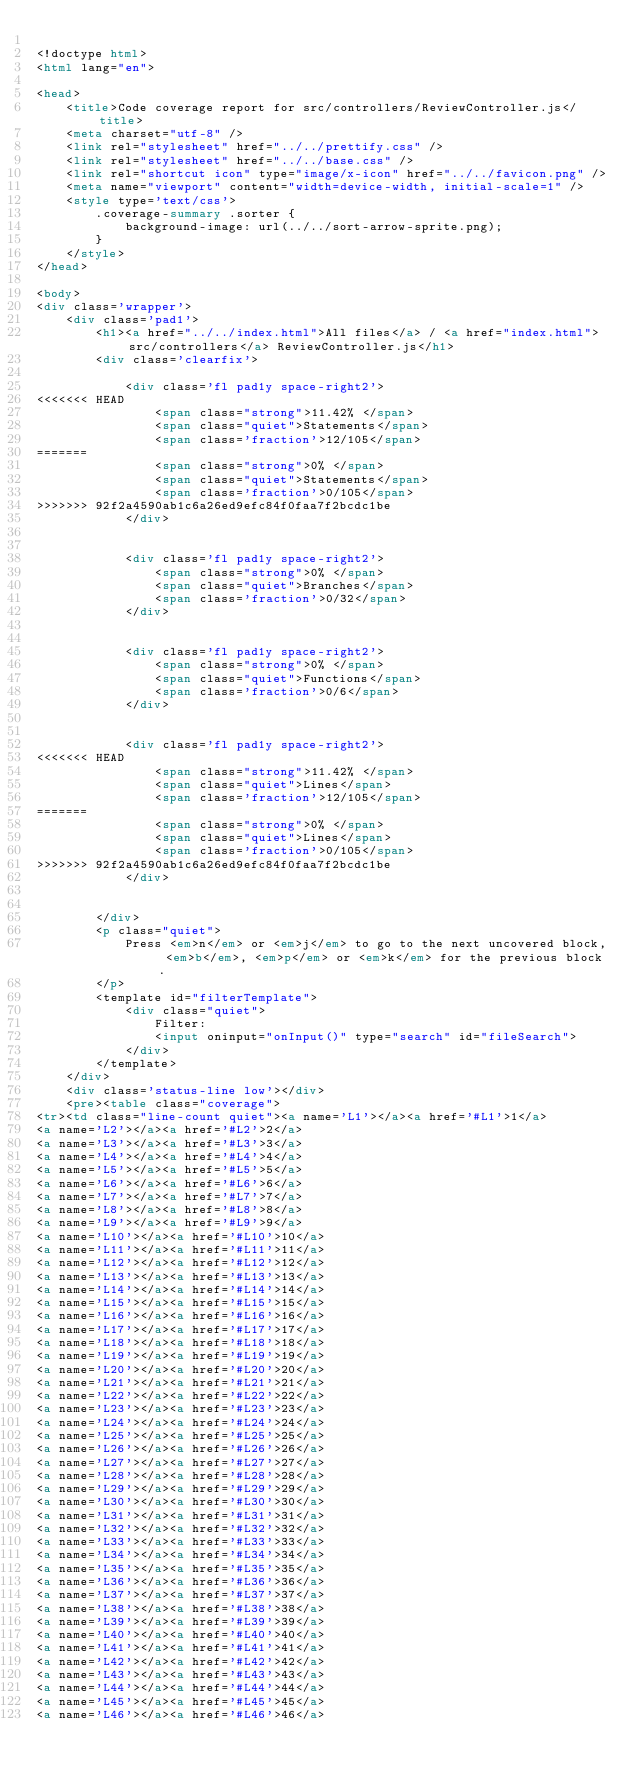<code> <loc_0><loc_0><loc_500><loc_500><_HTML_>
<!doctype html>
<html lang="en">

<head>
    <title>Code coverage report for src/controllers/ReviewController.js</title>
    <meta charset="utf-8" />
    <link rel="stylesheet" href="../../prettify.css" />
    <link rel="stylesheet" href="../../base.css" />
    <link rel="shortcut icon" type="image/x-icon" href="../../favicon.png" />
    <meta name="viewport" content="width=device-width, initial-scale=1" />
    <style type='text/css'>
        .coverage-summary .sorter {
            background-image: url(../../sort-arrow-sprite.png);
        }
    </style>
</head>
    
<body>
<div class='wrapper'>
    <div class='pad1'>
        <h1><a href="../../index.html">All files</a> / <a href="index.html">src/controllers</a> ReviewController.js</h1>
        <div class='clearfix'>
            
            <div class='fl pad1y space-right2'>
<<<<<<< HEAD
                <span class="strong">11.42% </span>
                <span class="quiet">Statements</span>
                <span class='fraction'>12/105</span>
=======
                <span class="strong">0% </span>
                <span class="quiet">Statements</span>
                <span class='fraction'>0/105</span>
>>>>>>> 92f2a4590ab1c6a26ed9efc84f0faa7f2bcdc1be
            </div>
        
            
            <div class='fl pad1y space-right2'>
                <span class="strong">0% </span>
                <span class="quiet">Branches</span>
                <span class='fraction'>0/32</span>
            </div>
        
            
            <div class='fl pad1y space-right2'>
                <span class="strong">0% </span>
                <span class="quiet">Functions</span>
                <span class='fraction'>0/6</span>
            </div>
        
            
            <div class='fl pad1y space-right2'>
<<<<<<< HEAD
                <span class="strong">11.42% </span>
                <span class="quiet">Lines</span>
                <span class='fraction'>12/105</span>
=======
                <span class="strong">0% </span>
                <span class="quiet">Lines</span>
                <span class='fraction'>0/105</span>
>>>>>>> 92f2a4590ab1c6a26ed9efc84f0faa7f2bcdc1be
            </div>
        
            
        </div>
        <p class="quiet">
            Press <em>n</em> or <em>j</em> to go to the next uncovered block, <em>b</em>, <em>p</em> or <em>k</em> for the previous block.
        </p>
        <template id="filterTemplate">
            <div class="quiet">
                Filter:
                <input oninput="onInput()" type="search" id="fileSearch">
            </div>
        </template>
    </div>
    <div class='status-line low'></div>
    <pre><table class="coverage">
<tr><td class="line-count quiet"><a name='L1'></a><a href='#L1'>1</a>
<a name='L2'></a><a href='#L2'>2</a>
<a name='L3'></a><a href='#L3'>3</a>
<a name='L4'></a><a href='#L4'>4</a>
<a name='L5'></a><a href='#L5'>5</a>
<a name='L6'></a><a href='#L6'>6</a>
<a name='L7'></a><a href='#L7'>7</a>
<a name='L8'></a><a href='#L8'>8</a>
<a name='L9'></a><a href='#L9'>9</a>
<a name='L10'></a><a href='#L10'>10</a>
<a name='L11'></a><a href='#L11'>11</a>
<a name='L12'></a><a href='#L12'>12</a>
<a name='L13'></a><a href='#L13'>13</a>
<a name='L14'></a><a href='#L14'>14</a>
<a name='L15'></a><a href='#L15'>15</a>
<a name='L16'></a><a href='#L16'>16</a>
<a name='L17'></a><a href='#L17'>17</a>
<a name='L18'></a><a href='#L18'>18</a>
<a name='L19'></a><a href='#L19'>19</a>
<a name='L20'></a><a href='#L20'>20</a>
<a name='L21'></a><a href='#L21'>21</a>
<a name='L22'></a><a href='#L22'>22</a>
<a name='L23'></a><a href='#L23'>23</a>
<a name='L24'></a><a href='#L24'>24</a>
<a name='L25'></a><a href='#L25'>25</a>
<a name='L26'></a><a href='#L26'>26</a>
<a name='L27'></a><a href='#L27'>27</a>
<a name='L28'></a><a href='#L28'>28</a>
<a name='L29'></a><a href='#L29'>29</a>
<a name='L30'></a><a href='#L30'>30</a>
<a name='L31'></a><a href='#L31'>31</a>
<a name='L32'></a><a href='#L32'>32</a>
<a name='L33'></a><a href='#L33'>33</a>
<a name='L34'></a><a href='#L34'>34</a>
<a name='L35'></a><a href='#L35'>35</a>
<a name='L36'></a><a href='#L36'>36</a>
<a name='L37'></a><a href='#L37'>37</a>
<a name='L38'></a><a href='#L38'>38</a>
<a name='L39'></a><a href='#L39'>39</a>
<a name='L40'></a><a href='#L40'>40</a>
<a name='L41'></a><a href='#L41'>41</a>
<a name='L42'></a><a href='#L42'>42</a>
<a name='L43'></a><a href='#L43'>43</a>
<a name='L44'></a><a href='#L44'>44</a>
<a name='L45'></a><a href='#L45'>45</a>
<a name='L46'></a><a href='#L46'>46</a></code> 